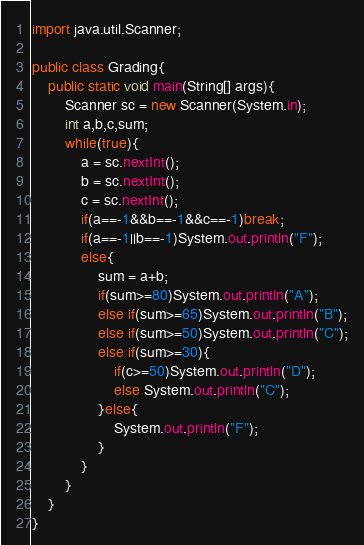<code> <loc_0><loc_0><loc_500><loc_500><_Java_>import java.util.Scanner;

public class Grading{
	public static void main(String[] args){
		Scanner sc = new Scanner(System.in);
		int a,b,c,sum;
		while(true){
			a = sc.nextInt();
			b = sc.nextInt();
			c = sc.nextInt();
			if(a==-1&&b==-1&&c==-1)break;
			if(a==-1||b==-1)System.out.println("F");
			else{
				sum = a+b;
				if(sum>=80)System.out.println("A");
				else if(sum>=65)System.out.println("B");
				else if(sum>=50)System.out.println("C");
				else if(sum>=30){
					if(c>=50)System.out.println("D");
					else System.out.println("C");
				}else{
					System.out.println("F");
				}
			}
		}
	}
}

</code> 